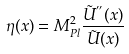Convert formula to latex. <formula><loc_0><loc_0><loc_500><loc_500>\eta ( x ) = M ^ { 2 } _ { P l } \frac { \tilde { U } ^ { ^ { \prime \prime } } ( x ) } { \tilde { U } ( x ) }</formula> 